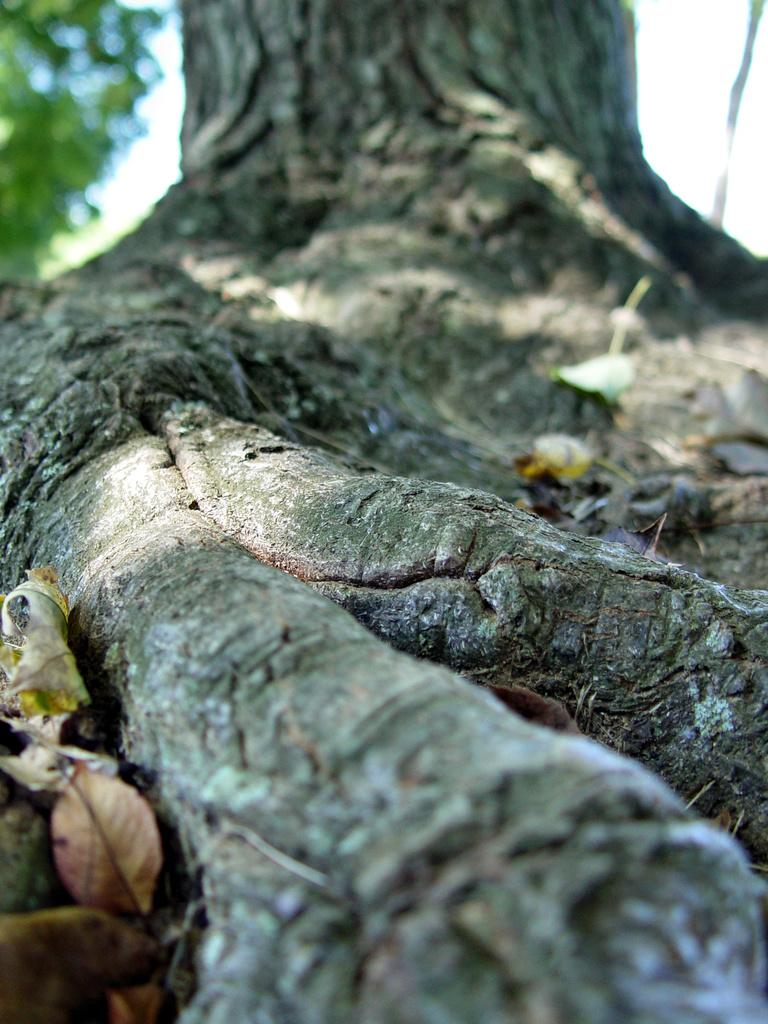What is the main subject of the picture? The main subject of the picture is a tree trunk. What can be seen around the tree trunk? There are dry leaves in the picture. What invention is being demonstrated in the picture? There is no invention being demonstrated in the picture; it features a tree trunk and dry leaves. How does the tree trunk aid in the digestion process of the leaves? The tree trunk does not aid in the digestion process of the leaves; it is a part of the tree that supports and transports nutrients. 